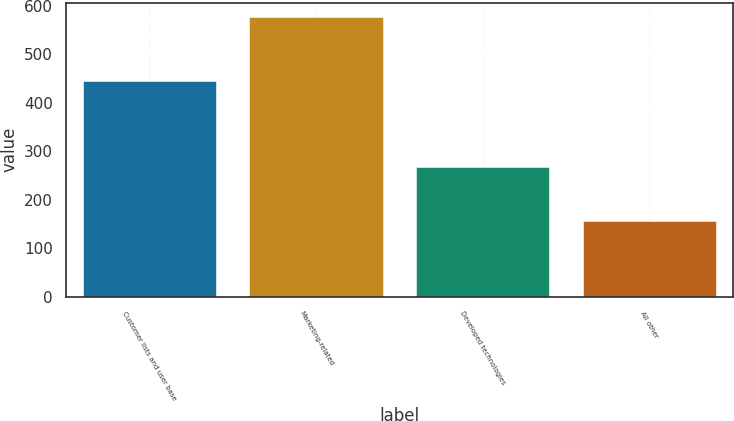Convert chart to OTSL. <chart><loc_0><loc_0><loc_500><loc_500><bar_chart><fcel>Customer lists and user base<fcel>Marketing-related<fcel>Developed technologies<fcel>All other<nl><fcel>445<fcel>578<fcel>269<fcel>157<nl></chart> 